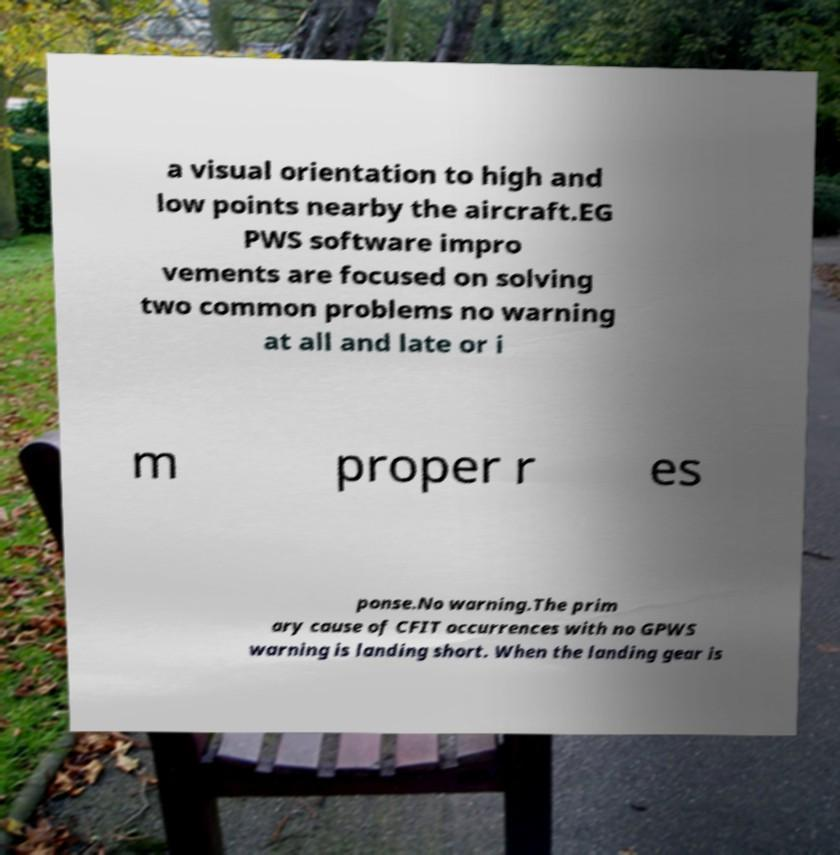Please read and relay the text visible in this image. What does it say? a visual orientation to high and low points nearby the aircraft.EG PWS software impro vements are focused on solving two common problems no warning at all and late or i m proper r es ponse.No warning.The prim ary cause of CFIT occurrences with no GPWS warning is landing short. When the landing gear is 